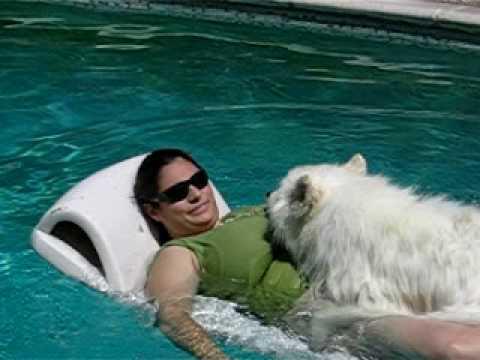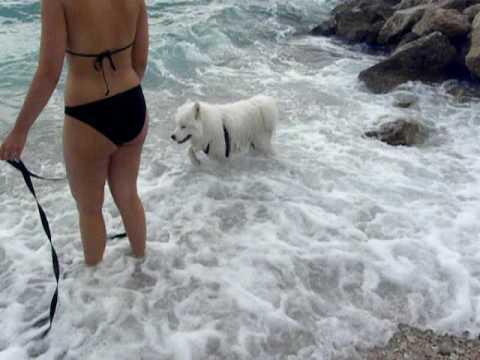The first image is the image on the left, the second image is the image on the right. Considering the images on both sides, is "There is a human with a white dog surrounded by water in the left image." valid? Answer yes or no. Yes. The first image is the image on the left, the second image is the image on the right. Given the left and right images, does the statement "There is at least one person visible" hold true? Answer yes or no. Yes. 